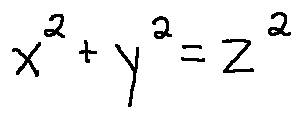Convert formula to latex. <formula><loc_0><loc_0><loc_500><loc_500>x ^ { 2 } + y ^ { 2 } = z ^ { 2 }</formula> 